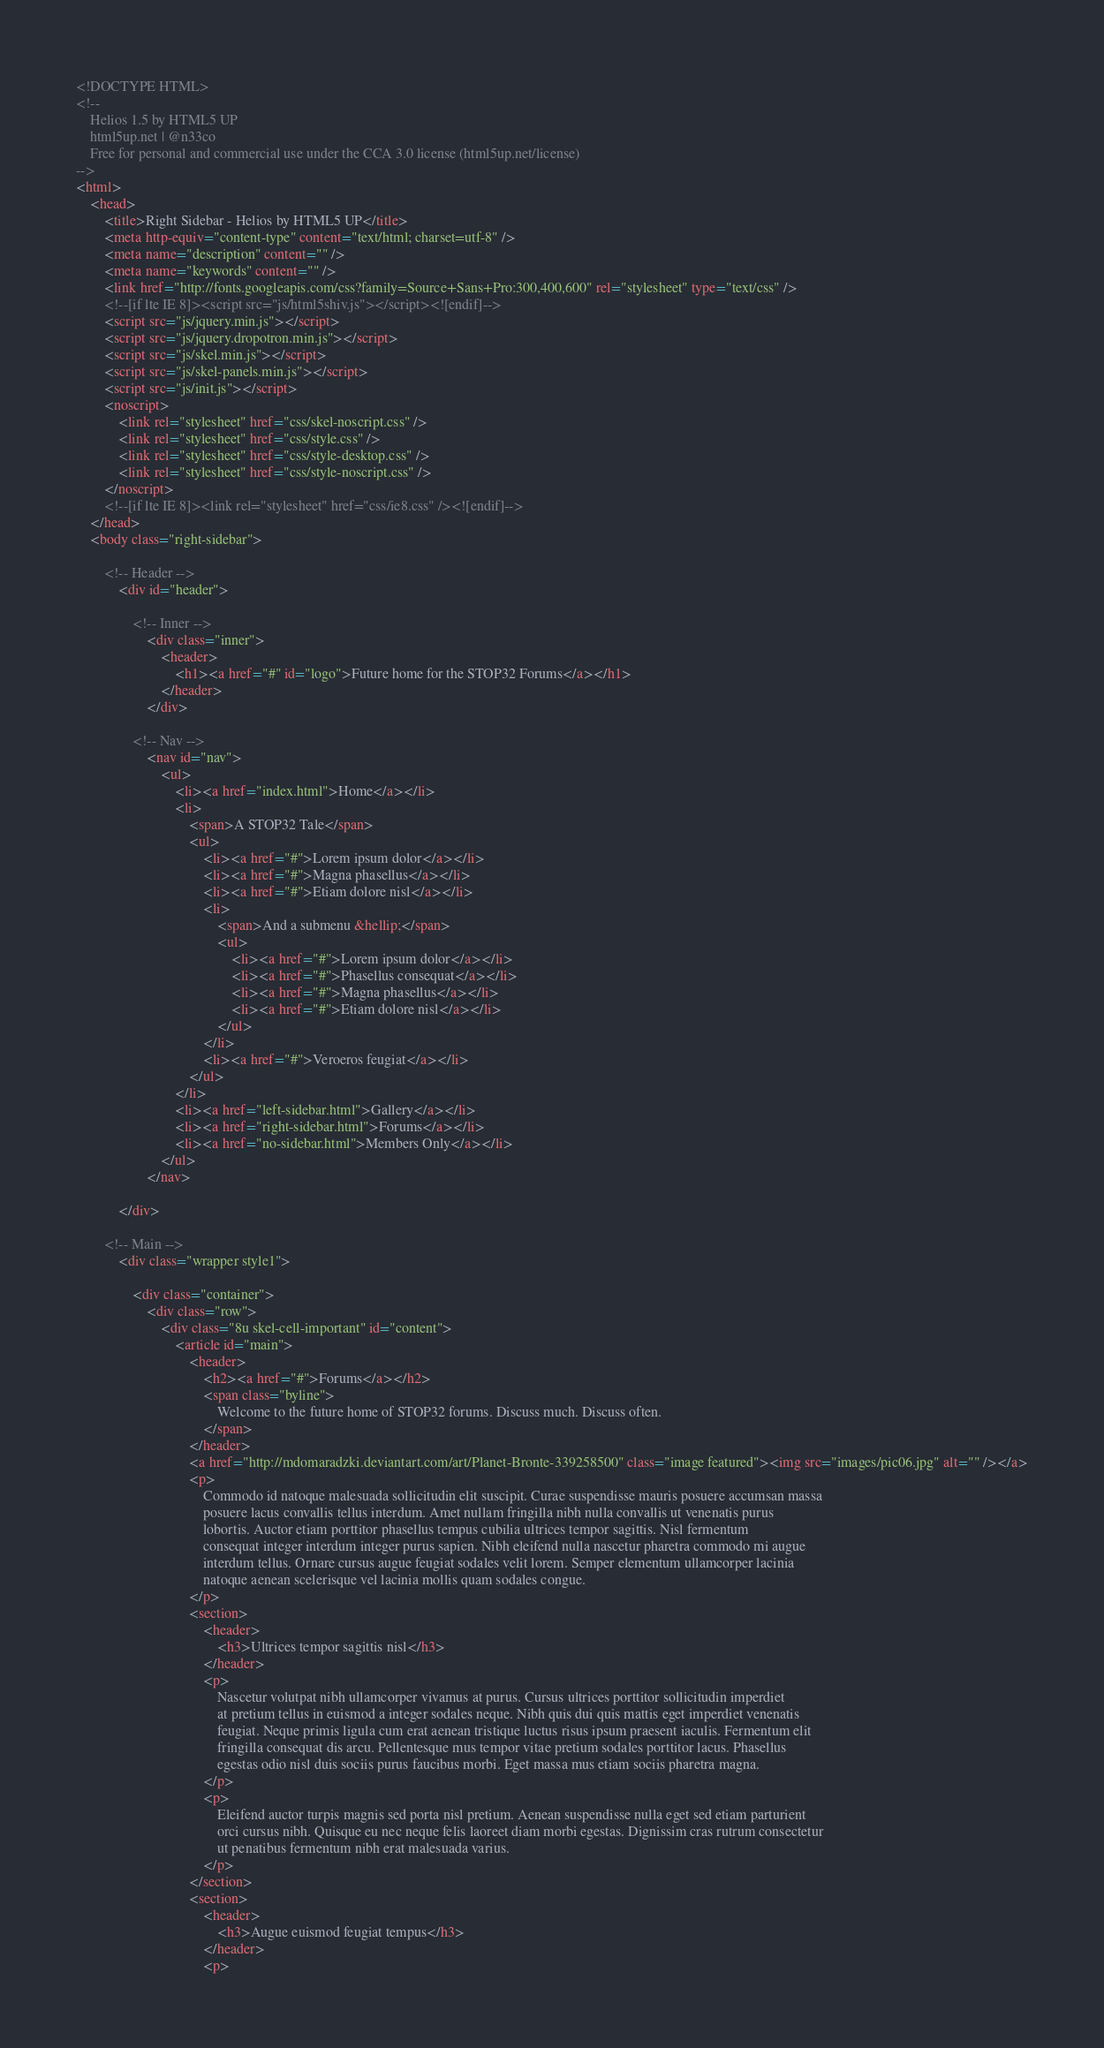Convert code to text. <code><loc_0><loc_0><loc_500><loc_500><_HTML_><!DOCTYPE HTML>
<!--
	Helios 1.5 by HTML5 UP
	html5up.net | @n33co
	Free for personal and commercial use under the CCA 3.0 license (html5up.net/license)
-->
<html>
	<head>
		<title>Right Sidebar - Helios by HTML5 UP</title>
		<meta http-equiv="content-type" content="text/html; charset=utf-8" />
		<meta name="description" content="" />
		<meta name="keywords" content="" />
		<link href="http://fonts.googleapis.com/css?family=Source+Sans+Pro:300,400,600" rel="stylesheet" type="text/css" />
		<!--[if lte IE 8]><script src="js/html5shiv.js"></script><![endif]-->
		<script src="js/jquery.min.js"></script>
		<script src="js/jquery.dropotron.min.js"></script>
		<script src="js/skel.min.js"></script>
		<script src="js/skel-panels.min.js"></script>
		<script src="js/init.js"></script>
		<noscript>
			<link rel="stylesheet" href="css/skel-noscript.css" />
			<link rel="stylesheet" href="css/style.css" />
			<link rel="stylesheet" href="css/style-desktop.css" />
			<link rel="stylesheet" href="css/style-noscript.css" />
		</noscript>
		<!--[if lte IE 8]><link rel="stylesheet" href="css/ie8.css" /><![endif]-->
	</head>
	<body class="right-sidebar">

		<!-- Header -->
			<div id="header">

				<!-- Inner -->
					<div class="inner">
						<header>
							<h1><a href="#" id="logo">Future home for the STOP32 Forums</a></h1>
						</header>
					</div>
				
				<!-- Nav -->
					<nav id="nav">
						<ul>
							<li><a href="index.html">Home</a></li>
							<li>
								<span>A STOP32 Tale</span>
								<ul>
									<li><a href="#">Lorem ipsum dolor</a></li>
									<li><a href="#">Magna phasellus</a></li>
									<li><a href="#">Etiam dolore nisl</a></li>
									<li>
										<span>And a submenu &hellip;</span>
										<ul>
											<li><a href="#">Lorem ipsum dolor</a></li>
											<li><a href="#">Phasellus consequat</a></li>
											<li><a href="#">Magna phasellus</a></li>
											<li><a href="#">Etiam dolore nisl</a></li>
										</ul>
									</li>
									<li><a href="#">Veroeros feugiat</a></li>
								</ul>
							</li>
							<li><a href="left-sidebar.html">Gallery</a></li>
							<li><a href="right-sidebar.html">Forums</a></li>
							<li><a href="no-sidebar.html">Members Only</a></li>
						</ul>
					</nav>

			</div>
			
		<!-- Main -->
			<div class="wrapper style1">

				<div class="container">
					<div class="row">
						<div class="8u skel-cell-important" id="content">
							<article id="main">
								<header>
									<h2><a href="#">Forums</a></h2>
									<span class="byline">
										Welcome to the future home of STOP32 forums. Discuss much. Discuss often.
									</span>
								</header>
								<a href="http://mdomaradzki.deviantart.com/art/Planet-Bronte-339258500" class="image featured"><img src="images/pic06.jpg" alt="" /></a>
								<p>
									Commodo id natoque malesuada sollicitudin elit suscipit. Curae suspendisse mauris posuere accumsan massa 
									posuere lacus convallis tellus interdum. Amet nullam fringilla nibh nulla convallis ut venenatis purus 
									lobortis. Auctor etiam porttitor phasellus tempus cubilia ultrices tempor sagittis. Nisl fermentum 
									consequat integer interdum integer purus sapien. Nibh eleifend nulla nascetur pharetra commodo mi augue 
									interdum tellus. Ornare cursus augue feugiat sodales velit lorem. Semper elementum ullamcorper lacinia 
									natoque aenean scelerisque vel lacinia mollis quam sodales congue.
								</p>
								<section>
									<header>
										<h3>Ultrices tempor sagittis nisl</h3>
									</header>
									<p>
										Nascetur volutpat nibh ullamcorper vivamus at purus. Cursus ultrices porttitor sollicitudin imperdiet
										at pretium tellus in euismod a integer sodales neque. Nibh quis dui quis mattis eget imperdiet venenatis 
										feugiat. Neque primis ligula cum erat aenean tristique luctus risus ipsum praesent iaculis. Fermentum elit 
										fringilla consequat dis arcu. Pellentesque mus tempor vitae pretium sodales porttitor lacus. Phasellus 
										egestas odio nisl duis sociis purus faucibus morbi. Eget massa mus etiam sociis pharetra magna. 
									</p>
									<p>
										Eleifend auctor turpis magnis sed porta nisl pretium. Aenean suspendisse nulla eget sed etiam parturient 
										orci cursus nibh. Quisque eu nec neque felis laoreet diam morbi egestas. Dignissim cras rutrum consectetur 
										ut penatibus fermentum nibh erat malesuada varius. 
									</p>
								</section>
								<section>
									<header>
										<h3>Augue euismod feugiat tempus</h3>
									</header>
									<p></code> 